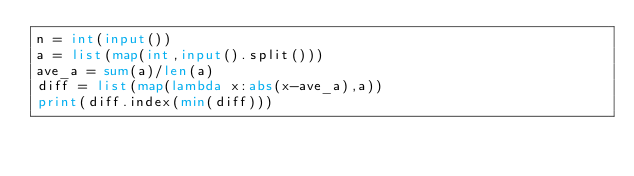Convert code to text. <code><loc_0><loc_0><loc_500><loc_500><_Python_>n = int(input())
a = list(map(int,input().split()))
ave_a = sum(a)/len(a)
diff = list(map(lambda x:abs(x-ave_a),a))
print(diff.index(min(diff)))</code> 